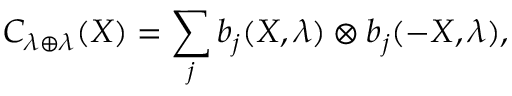<formula> <loc_0><loc_0><loc_500><loc_500>C _ { \lambda \oplus \lambda } ( X ) = \sum _ { j } b _ { j } ( X , \lambda ) \otimes b _ { j } ( - X , \lambda ) ,</formula> 